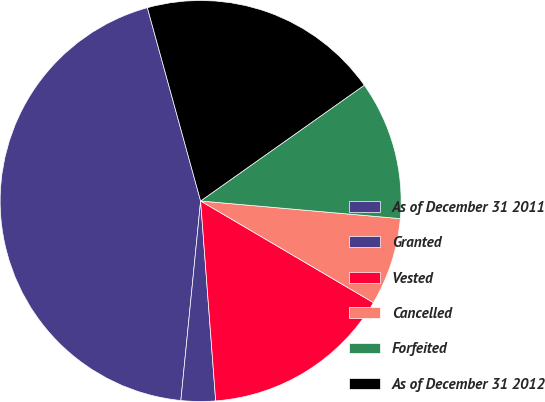Convert chart. <chart><loc_0><loc_0><loc_500><loc_500><pie_chart><fcel>As of December 31 2011<fcel>Granted<fcel>Vested<fcel>Cancelled<fcel>Forfeited<fcel>As of December 31 2012<nl><fcel>44.15%<fcel>2.77%<fcel>15.34%<fcel>7.06%<fcel>11.2%<fcel>19.48%<nl></chart> 